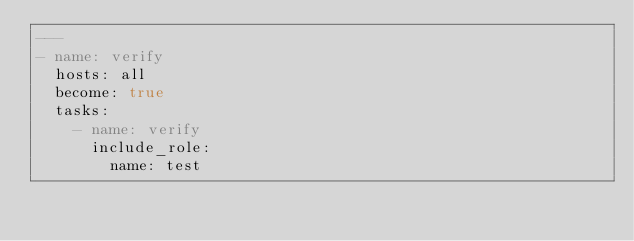<code> <loc_0><loc_0><loc_500><loc_500><_YAML_>---
- name: verify
  hosts: all
  become: true
  tasks:
    - name: verify
      include_role:
        name: test
</code> 